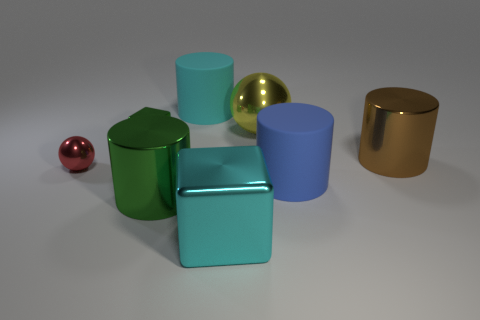Add 1 tiny green blocks. How many objects exist? 9 Subtract all balls. How many objects are left? 6 Subtract 0 purple cubes. How many objects are left? 8 Subtract all blue cylinders. Subtract all small cyan metal things. How many objects are left? 7 Add 1 large yellow metallic spheres. How many large yellow metallic spheres are left? 2 Add 5 brown rubber cylinders. How many brown rubber cylinders exist? 5 